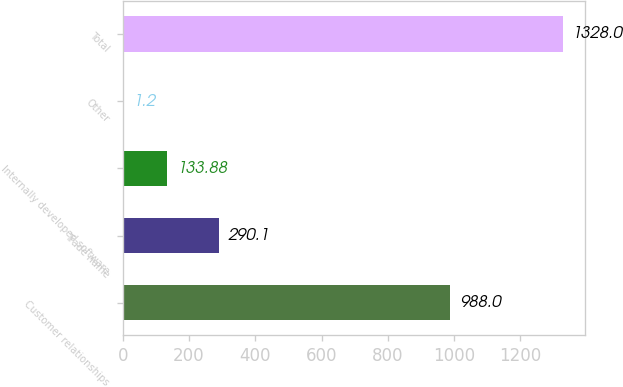Convert chart. <chart><loc_0><loc_0><loc_500><loc_500><bar_chart><fcel>Customer relationships<fcel>Trade name<fcel>Internally developed software<fcel>Other<fcel>Total<nl><fcel>988<fcel>290.1<fcel>133.88<fcel>1.2<fcel>1328<nl></chart> 